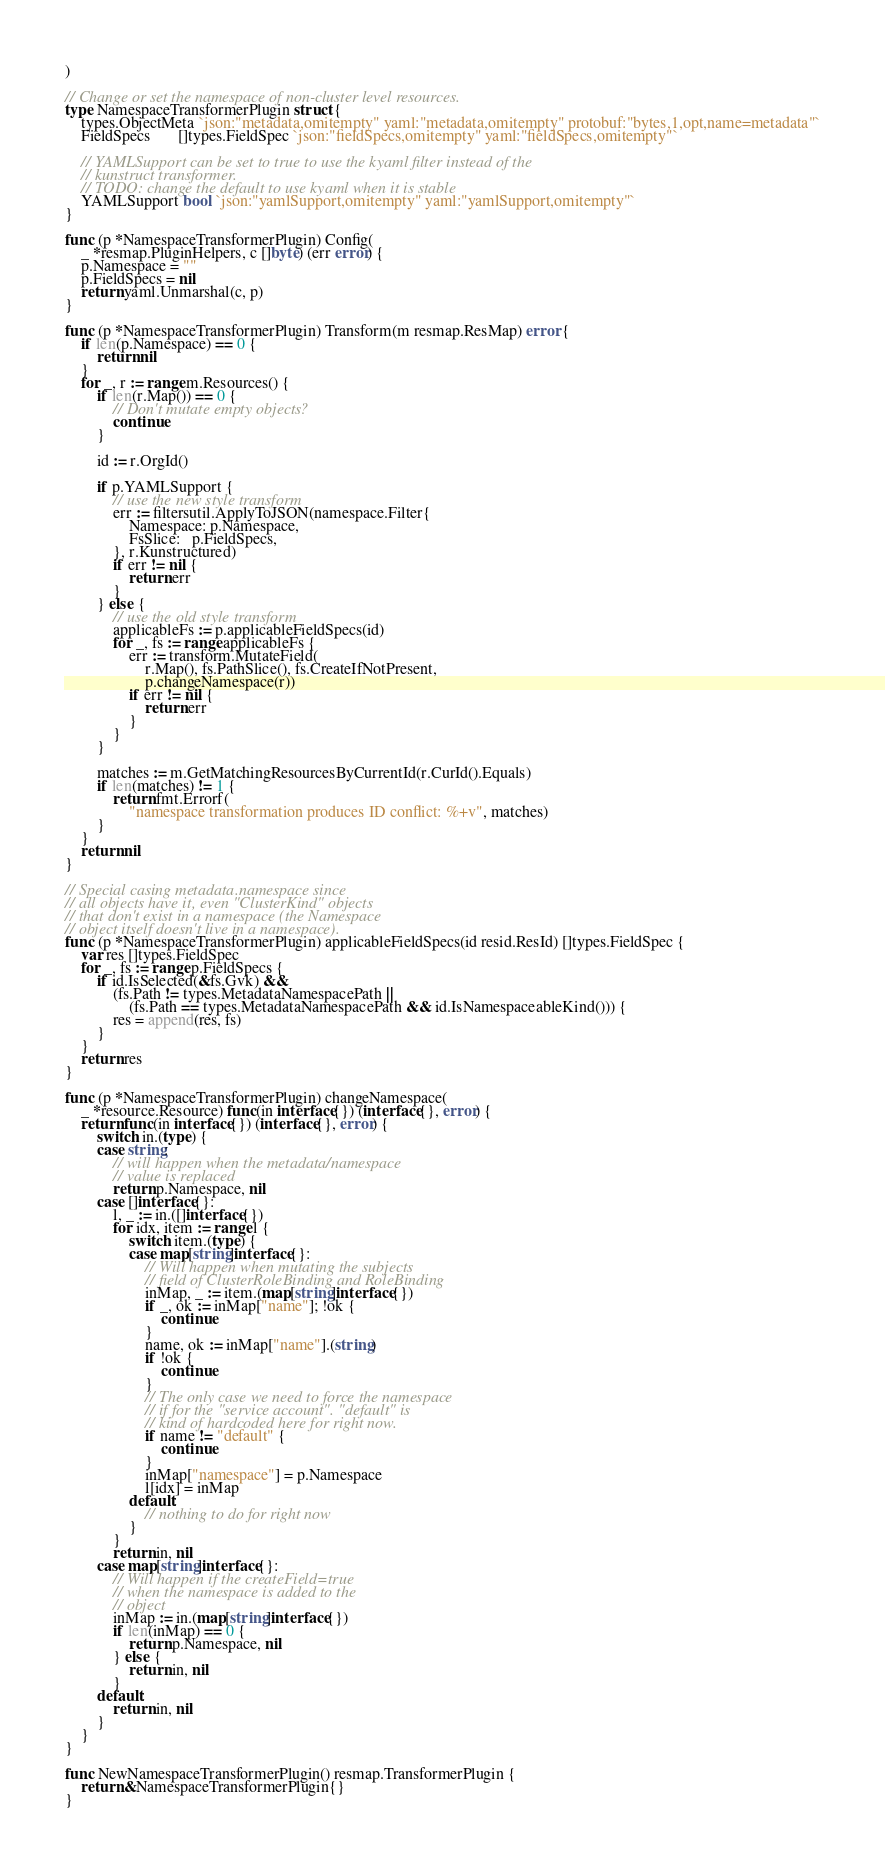<code> <loc_0><loc_0><loc_500><loc_500><_Go_>)

// Change or set the namespace of non-cluster level resources.
type NamespaceTransformerPlugin struct {
	types.ObjectMeta `json:"metadata,omitempty" yaml:"metadata,omitempty" protobuf:"bytes,1,opt,name=metadata"`
	FieldSpecs       []types.FieldSpec `json:"fieldSpecs,omitempty" yaml:"fieldSpecs,omitempty"`

	// YAMLSupport can be set to true to use the kyaml filter instead of the
	// kunstruct transformer.
	// TODO: change the default to use kyaml when it is stable
	YAMLSupport bool `json:"yamlSupport,omitempty" yaml:"yamlSupport,omitempty"`
}

func (p *NamespaceTransformerPlugin) Config(
	_ *resmap.PluginHelpers, c []byte) (err error) {
	p.Namespace = ""
	p.FieldSpecs = nil
	return yaml.Unmarshal(c, p)
}

func (p *NamespaceTransformerPlugin) Transform(m resmap.ResMap) error {
	if len(p.Namespace) == 0 {
		return nil
	}
	for _, r := range m.Resources() {
		if len(r.Map()) == 0 {
			// Don't mutate empty objects?
			continue
		}

		id := r.OrgId()

		if p.YAMLSupport {
			// use the new style transform
			err := filtersutil.ApplyToJSON(namespace.Filter{
				Namespace: p.Namespace,
				FsSlice:   p.FieldSpecs,
			}, r.Kunstructured)
			if err != nil {
				return err
			}
		} else {
			// use the old style transform
			applicableFs := p.applicableFieldSpecs(id)
			for _, fs := range applicableFs {
				err := transform.MutateField(
					r.Map(), fs.PathSlice(), fs.CreateIfNotPresent,
					p.changeNamespace(r))
				if err != nil {
					return err
				}
			}
		}

		matches := m.GetMatchingResourcesByCurrentId(r.CurId().Equals)
		if len(matches) != 1 {
			return fmt.Errorf(
				"namespace transformation produces ID conflict: %+v", matches)
		}
	}
	return nil
}

// Special casing metadata.namespace since
// all objects have it, even "ClusterKind" objects
// that don't exist in a namespace (the Namespace
// object itself doesn't live in a namespace).
func (p *NamespaceTransformerPlugin) applicableFieldSpecs(id resid.ResId) []types.FieldSpec {
	var res []types.FieldSpec
	for _, fs := range p.FieldSpecs {
		if id.IsSelected(&fs.Gvk) &&
			(fs.Path != types.MetadataNamespacePath ||
				(fs.Path == types.MetadataNamespacePath && id.IsNamespaceableKind())) {
			res = append(res, fs)
		}
	}
	return res
}

func (p *NamespaceTransformerPlugin) changeNamespace(
	_ *resource.Resource) func(in interface{}) (interface{}, error) {
	return func(in interface{}) (interface{}, error) {
		switch in.(type) {
		case string:
			// will happen when the metadata/namespace
			// value is replaced
			return p.Namespace, nil
		case []interface{}:
			l, _ := in.([]interface{})
			for idx, item := range l {
				switch item.(type) {
				case map[string]interface{}:
					// Will happen when mutating the subjects
					// field of ClusterRoleBinding and RoleBinding
					inMap, _ := item.(map[string]interface{})
					if _, ok := inMap["name"]; !ok {
						continue
					}
					name, ok := inMap["name"].(string)
					if !ok {
						continue
					}
					// The only case we need to force the namespace
					// if for the "service account". "default" is
					// kind of hardcoded here for right now.
					if name != "default" {
						continue
					}
					inMap["namespace"] = p.Namespace
					l[idx] = inMap
				default:
					// nothing to do for right now
				}
			}
			return in, nil
		case map[string]interface{}:
			// Will happen if the createField=true
			// when the namespace is added to the
			// object
			inMap := in.(map[string]interface{})
			if len(inMap) == 0 {
				return p.Namespace, nil
			} else {
				return in, nil
			}
		default:
			return in, nil
		}
	}
}

func NewNamespaceTransformerPlugin() resmap.TransformerPlugin {
	return &NamespaceTransformerPlugin{}
}
</code> 